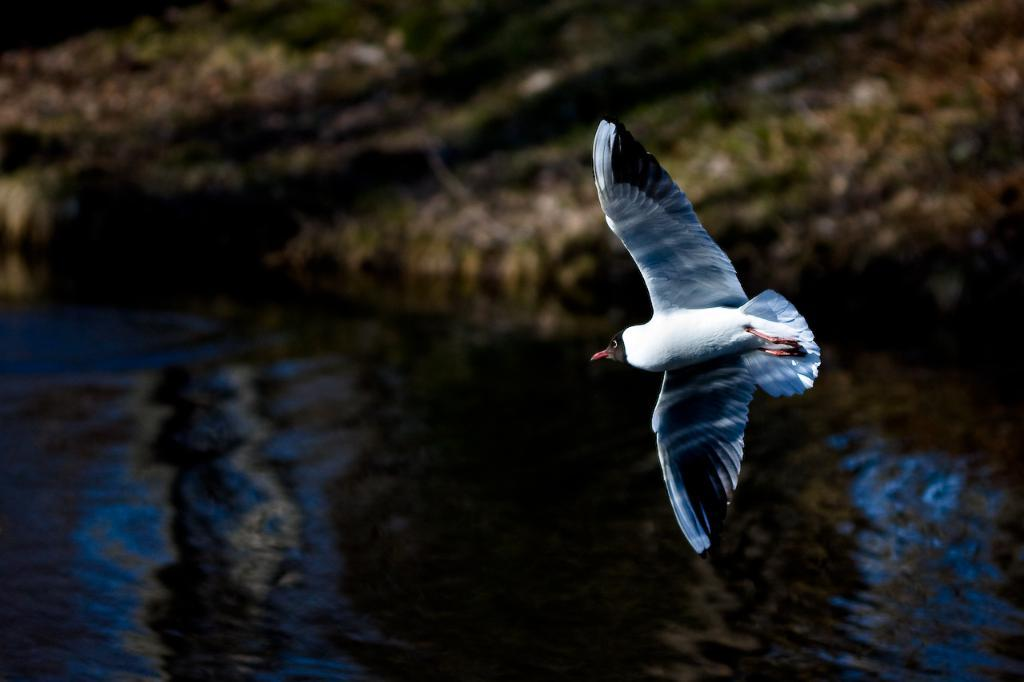What is the main subject of the image? There is a bird flying in the image. On which side of the image is the bird located? The bird is on the right side of the image. What is visible at the bottom of the image? There is water at the bottom of the image. What can be seen in the background of the image? There is land visible in the background of the image. What type of office furniture is present in the image? There is no office furniture present in the image; it features a bird flying over water with land visible in the background. 